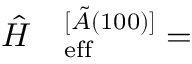Convert formula to latex. <formula><loc_0><loc_0><loc_500><loc_500>\begin{array} { r l } { \hat { H } } & _ { e } f f ^ { [ \tilde { A } ( 1 0 0 ) ] } = } \end{array}</formula> 